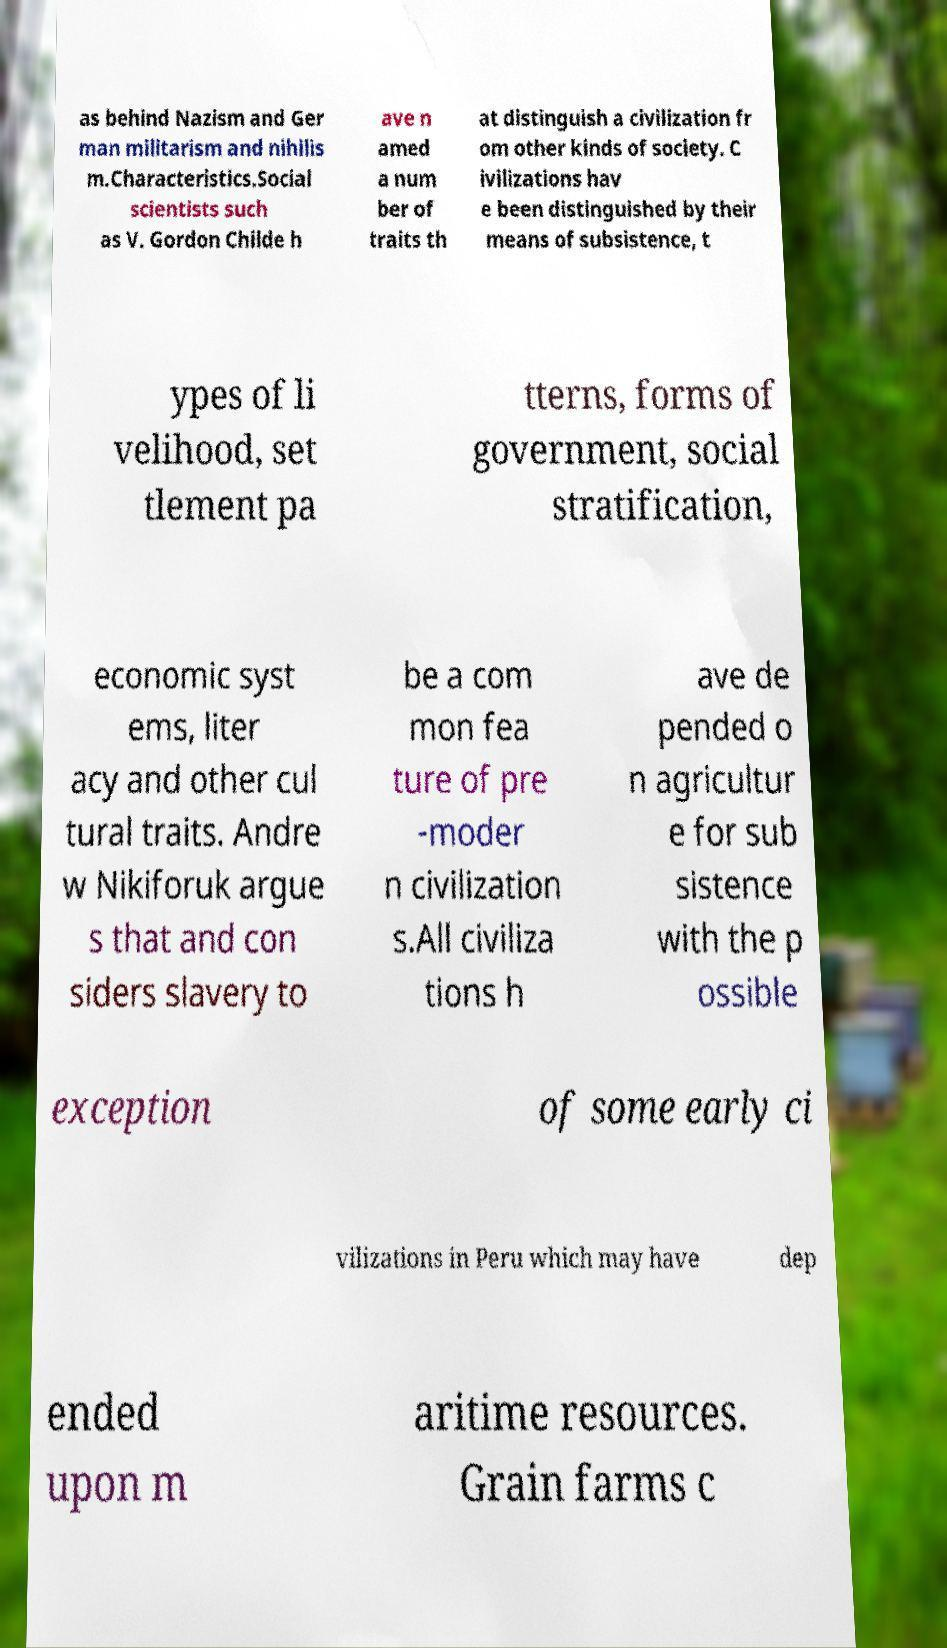Please read and relay the text visible in this image. What does it say? as behind Nazism and Ger man militarism and nihilis m.Characteristics.Social scientists such as V. Gordon Childe h ave n amed a num ber of traits th at distinguish a civilization fr om other kinds of society. C ivilizations hav e been distinguished by their means of subsistence, t ypes of li velihood, set tlement pa tterns, forms of government, social stratification, economic syst ems, liter acy and other cul tural traits. Andre w Nikiforuk argue s that and con siders slavery to be a com mon fea ture of pre -moder n civilization s.All civiliza tions h ave de pended o n agricultur e for sub sistence with the p ossible exception of some early ci vilizations in Peru which may have dep ended upon m aritime resources. Grain farms c 